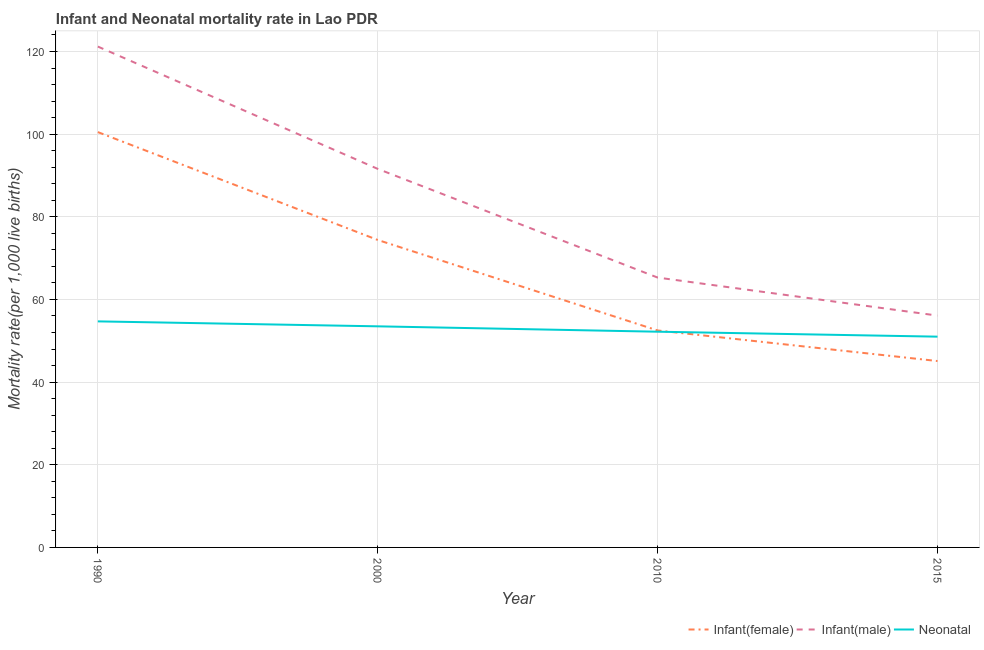Does the line corresponding to infant mortality rate(male) intersect with the line corresponding to neonatal mortality rate?
Offer a very short reply. No. Is the number of lines equal to the number of legend labels?
Provide a short and direct response. Yes. What is the infant mortality rate(male) in 2010?
Provide a short and direct response. 65.3. Across all years, what is the maximum infant mortality rate(male)?
Ensure brevity in your answer.  121.2. Across all years, what is the minimum infant mortality rate(female)?
Provide a short and direct response. 45.1. In which year was the neonatal mortality rate minimum?
Provide a short and direct response. 2015. What is the total infant mortality rate(female) in the graph?
Your answer should be very brief. 272.5. What is the difference between the infant mortality rate(female) in 1990 and that in 2000?
Make the answer very short. 26.1. What is the difference between the infant mortality rate(male) in 2015 and the infant mortality rate(female) in 2000?
Keep it short and to the point. -18.3. What is the average infant mortality rate(male) per year?
Ensure brevity in your answer.  83.55. In the year 2015, what is the difference between the infant mortality rate(female) and infant mortality rate(male)?
Your answer should be compact. -11. What is the ratio of the infant mortality rate(male) in 1990 to that in 2010?
Offer a terse response. 1.86. Is the neonatal mortality rate in 1990 less than that in 2015?
Ensure brevity in your answer.  No. Is the difference between the infant mortality rate(female) in 2000 and 2010 greater than the difference between the neonatal mortality rate in 2000 and 2010?
Keep it short and to the point. Yes. What is the difference between the highest and the second highest infant mortality rate(female)?
Give a very brief answer. 26.1. What is the difference between the highest and the lowest neonatal mortality rate?
Provide a short and direct response. 3.7. In how many years, is the infant mortality rate(male) greater than the average infant mortality rate(male) taken over all years?
Provide a short and direct response. 2. Is the sum of the infant mortality rate(male) in 2000 and 2010 greater than the maximum neonatal mortality rate across all years?
Provide a succinct answer. Yes. Does the infant mortality rate(female) monotonically increase over the years?
Provide a succinct answer. No. Is the infant mortality rate(female) strictly greater than the neonatal mortality rate over the years?
Ensure brevity in your answer.  No. Are the values on the major ticks of Y-axis written in scientific E-notation?
Your response must be concise. No. Does the graph contain any zero values?
Your response must be concise. No. Does the graph contain grids?
Offer a terse response. Yes. How are the legend labels stacked?
Ensure brevity in your answer.  Horizontal. What is the title of the graph?
Offer a very short reply. Infant and Neonatal mortality rate in Lao PDR. What is the label or title of the X-axis?
Offer a terse response. Year. What is the label or title of the Y-axis?
Ensure brevity in your answer.  Mortality rate(per 1,0 live births). What is the Mortality rate(per 1,000 live births) of Infant(female) in 1990?
Provide a short and direct response. 100.5. What is the Mortality rate(per 1,000 live births) of Infant(male) in 1990?
Give a very brief answer. 121.2. What is the Mortality rate(per 1,000 live births) of Neonatal  in 1990?
Provide a short and direct response. 54.7. What is the Mortality rate(per 1,000 live births) in Infant(female) in 2000?
Make the answer very short. 74.4. What is the Mortality rate(per 1,000 live births) in Infant(male) in 2000?
Make the answer very short. 91.6. What is the Mortality rate(per 1,000 live births) in Neonatal  in 2000?
Make the answer very short. 53.5. What is the Mortality rate(per 1,000 live births) of Infant(female) in 2010?
Offer a terse response. 52.5. What is the Mortality rate(per 1,000 live births) of Infant(male) in 2010?
Ensure brevity in your answer.  65.3. What is the Mortality rate(per 1,000 live births) in Neonatal  in 2010?
Offer a terse response. 52.2. What is the Mortality rate(per 1,000 live births) of Infant(female) in 2015?
Give a very brief answer. 45.1. What is the Mortality rate(per 1,000 live births) in Infant(male) in 2015?
Your answer should be very brief. 56.1. Across all years, what is the maximum Mortality rate(per 1,000 live births) of Infant(female)?
Keep it short and to the point. 100.5. Across all years, what is the maximum Mortality rate(per 1,000 live births) in Infant(male)?
Provide a succinct answer. 121.2. Across all years, what is the maximum Mortality rate(per 1,000 live births) of Neonatal ?
Provide a succinct answer. 54.7. Across all years, what is the minimum Mortality rate(per 1,000 live births) of Infant(female)?
Offer a terse response. 45.1. Across all years, what is the minimum Mortality rate(per 1,000 live births) in Infant(male)?
Keep it short and to the point. 56.1. Across all years, what is the minimum Mortality rate(per 1,000 live births) of Neonatal ?
Your response must be concise. 51. What is the total Mortality rate(per 1,000 live births) in Infant(female) in the graph?
Keep it short and to the point. 272.5. What is the total Mortality rate(per 1,000 live births) of Infant(male) in the graph?
Keep it short and to the point. 334.2. What is the total Mortality rate(per 1,000 live births) in Neonatal  in the graph?
Keep it short and to the point. 211.4. What is the difference between the Mortality rate(per 1,000 live births) of Infant(female) in 1990 and that in 2000?
Give a very brief answer. 26.1. What is the difference between the Mortality rate(per 1,000 live births) of Infant(male) in 1990 and that in 2000?
Your answer should be very brief. 29.6. What is the difference between the Mortality rate(per 1,000 live births) of Infant(female) in 1990 and that in 2010?
Ensure brevity in your answer.  48. What is the difference between the Mortality rate(per 1,000 live births) of Infant(male) in 1990 and that in 2010?
Offer a terse response. 55.9. What is the difference between the Mortality rate(per 1,000 live births) in Infant(female) in 1990 and that in 2015?
Ensure brevity in your answer.  55.4. What is the difference between the Mortality rate(per 1,000 live births) of Infant(male) in 1990 and that in 2015?
Keep it short and to the point. 65.1. What is the difference between the Mortality rate(per 1,000 live births) in Neonatal  in 1990 and that in 2015?
Your response must be concise. 3.7. What is the difference between the Mortality rate(per 1,000 live births) in Infant(female) in 2000 and that in 2010?
Provide a succinct answer. 21.9. What is the difference between the Mortality rate(per 1,000 live births) of Infant(male) in 2000 and that in 2010?
Offer a terse response. 26.3. What is the difference between the Mortality rate(per 1,000 live births) of Neonatal  in 2000 and that in 2010?
Give a very brief answer. 1.3. What is the difference between the Mortality rate(per 1,000 live births) of Infant(female) in 2000 and that in 2015?
Your answer should be compact. 29.3. What is the difference between the Mortality rate(per 1,000 live births) of Infant(male) in 2000 and that in 2015?
Provide a short and direct response. 35.5. What is the difference between the Mortality rate(per 1,000 live births) of Infant(female) in 2010 and that in 2015?
Make the answer very short. 7.4. What is the difference between the Mortality rate(per 1,000 live births) in Infant(male) in 2010 and that in 2015?
Offer a very short reply. 9.2. What is the difference between the Mortality rate(per 1,000 live births) in Neonatal  in 2010 and that in 2015?
Make the answer very short. 1.2. What is the difference between the Mortality rate(per 1,000 live births) of Infant(female) in 1990 and the Mortality rate(per 1,000 live births) of Infant(male) in 2000?
Offer a very short reply. 8.9. What is the difference between the Mortality rate(per 1,000 live births) of Infant(female) in 1990 and the Mortality rate(per 1,000 live births) of Neonatal  in 2000?
Provide a short and direct response. 47. What is the difference between the Mortality rate(per 1,000 live births) in Infant(male) in 1990 and the Mortality rate(per 1,000 live births) in Neonatal  in 2000?
Your answer should be very brief. 67.7. What is the difference between the Mortality rate(per 1,000 live births) of Infant(female) in 1990 and the Mortality rate(per 1,000 live births) of Infant(male) in 2010?
Your answer should be compact. 35.2. What is the difference between the Mortality rate(per 1,000 live births) in Infant(female) in 1990 and the Mortality rate(per 1,000 live births) in Neonatal  in 2010?
Your response must be concise. 48.3. What is the difference between the Mortality rate(per 1,000 live births) of Infant(male) in 1990 and the Mortality rate(per 1,000 live births) of Neonatal  in 2010?
Provide a succinct answer. 69. What is the difference between the Mortality rate(per 1,000 live births) in Infant(female) in 1990 and the Mortality rate(per 1,000 live births) in Infant(male) in 2015?
Your response must be concise. 44.4. What is the difference between the Mortality rate(per 1,000 live births) of Infant(female) in 1990 and the Mortality rate(per 1,000 live births) of Neonatal  in 2015?
Provide a succinct answer. 49.5. What is the difference between the Mortality rate(per 1,000 live births) in Infant(male) in 1990 and the Mortality rate(per 1,000 live births) in Neonatal  in 2015?
Offer a very short reply. 70.2. What is the difference between the Mortality rate(per 1,000 live births) in Infant(male) in 2000 and the Mortality rate(per 1,000 live births) in Neonatal  in 2010?
Offer a very short reply. 39.4. What is the difference between the Mortality rate(per 1,000 live births) of Infant(female) in 2000 and the Mortality rate(per 1,000 live births) of Neonatal  in 2015?
Provide a short and direct response. 23.4. What is the difference between the Mortality rate(per 1,000 live births) of Infant(male) in 2000 and the Mortality rate(per 1,000 live births) of Neonatal  in 2015?
Provide a short and direct response. 40.6. What is the difference between the Mortality rate(per 1,000 live births) in Infant(female) in 2010 and the Mortality rate(per 1,000 live births) in Neonatal  in 2015?
Ensure brevity in your answer.  1.5. What is the average Mortality rate(per 1,000 live births) of Infant(female) per year?
Your response must be concise. 68.12. What is the average Mortality rate(per 1,000 live births) in Infant(male) per year?
Your answer should be very brief. 83.55. What is the average Mortality rate(per 1,000 live births) of Neonatal  per year?
Make the answer very short. 52.85. In the year 1990, what is the difference between the Mortality rate(per 1,000 live births) in Infant(female) and Mortality rate(per 1,000 live births) in Infant(male)?
Offer a terse response. -20.7. In the year 1990, what is the difference between the Mortality rate(per 1,000 live births) in Infant(female) and Mortality rate(per 1,000 live births) in Neonatal ?
Provide a succinct answer. 45.8. In the year 1990, what is the difference between the Mortality rate(per 1,000 live births) of Infant(male) and Mortality rate(per 1,000 live births) of Neonatal ?
Ensure brevity in your answer.  66.5. In the year 2000, what is the difference between the Mortality rate(per 1,000 live births) in Infant(female) and Mortality rate(per 1,000 live births) in Infant(male)?
Provide a short and direct response. -17.2. In the year 2000, what is the difference between the Mortality rate(per 1,000 live births) of Infant(female) and Mortality rate(per 1,000 live births) of Neonatal ?
Provide a succinct answer. 20.9. In the year 2000, what is the difference between the Mortality rate(per 1,000 live births) in Infant(male) and Mortality rate(per 1,000 live births) in Neonatal ?
Ensure brevity in your answer.  38.1. In the year 2010, what is the difference between the Mortality rate(per 1,000 live births) in Infant(female) and Mortality rate(per 1,000 live births) in Neonatal ?
Provide a short and direct response. 0.3. In the year 2010, what is the difference between the Mortality rate(per 1,000 live births) of Infant(male) and Mortality rate(per 1,000 live births) of Neonatal ?
Your response must be concise. 13.1. In the year 2015, what is the difference between the Mortality rate(per 1,000 live births) of Infant(male) and Mortality rate(per 1,000 live births) of Neonatal ?
Give a very brief answer. 5.1. What is the ratio of the Mortality rate(per 1,000 live births) in Infant(female) in 1990 to that in 2000?
Your response must be concise. 1.35. What is the ratio of the Mortality rate(per 1,000 live births) of Infant(male) in 1990 to that in 2000?
Ensure brevity in your answer.  1.32. What is the ratio of the Mortality rate(per 1,000 live births) in Neonatal  in 1990 to that in 2000?
Provide a short and direct response. 1.02. What is the ratio of the Mortality rate(per 1,000 live births) of Infant(female) in 1990 to that in 2010?
Provide a succinct answer. 1.91. What is the ratio of the Mortality rate(per 1,000 live births) in Infant(male) in 1990 to that in 2010?
Offer a very short reply. 1.86. What is the ratio of the Mortality rate(per 1,000 live births) of Neonatal  in 1990 to that in 2010?
Ensure brevity in your answer.  1.05. What is the ratio of the Mortality rate(per 1,000 live births) of Infant(female) in 1990 to that in 2015?
Your answer should be very brief. 2.23. What is the ratio of the Mortality rate(per 1,000 live births) in Infant(male) in 1990 to that in 2015?
Your answer should be very brief. 2.16. What is the ratio of the Mortality rate(per 1,000 live births) in Neonatal  in 1990 to that in 2015?
Make the answer very short. 1.07. What is the ratio of the Mortality rate(per 1,000 live births) in Infant(female) in 2000 to that in 2010?
Keep it short and to the point. 1.42. What is the ratio of the Mortality rate(per 1,000 live births) in Infant(male) in 2000 to that in 2010?
Your response must be concise. 1.4. What is the ratio of the Mortality rate(per 1,000 live births) of Neonatal  in 2000 to that in 2010?
Keep it short and to the point. 1.02. What is the ratio of the Mortality rate(per 1,000 live births) in Infant(female) in 2000 to that in 2015?
Keep it short and to the point. 1.65. What is the ratio of the Mortality rate(per 1,000 live births) in Infant(male) in 2000 to that in 2015?
Ensure brevity in your answer.  1.63. What is the ratio of the Mortality rate(per 1,000 live births) in Neonatal  in 2000 to that in 2015?
Your response must be concise. 1.05. What is the ratio of the Mortality rate(per 1,000 live births) of Infant(female) in 2010 to that in 2015?
Your answer should be very brief. 1.16. What is the ratio of the Mortality rate(per 1,000 live births) in Infant(male) in 2010 to that in 2015?
Offer a very short reply. 1.16. What is the ratio of the Mortality rate(per 1,000 live births) in Neonatal  in 2010 to that in 2015?
Provide a succinct answer. 1.02. What is the difference between the highest and the second highest Mortality rate(per 1,000 live births) of Infant(female)?
Offer a very short reply. 26.1. What is the difference between the highest and the second highest Mortality rate(per 1,000 live births) of Infant(male)?
Offer a terse response. 29.6. What is the difference between the highest and the lowest Mortality rate(per 1,000 live births) of Infant(female)?
Provide a short and direct response. 55.4. What is the difference between the highest and the lowest Mortality rate(per 1,000 live births) in Infant(male)?
Ensure brevity in your answer.  65.1. 